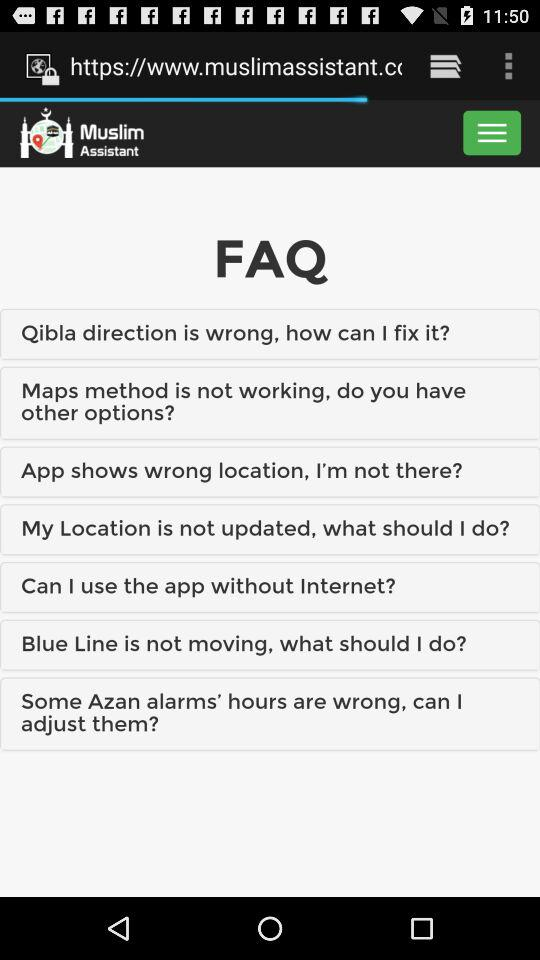What is the app name? The app name is "Muslim Assistant". 